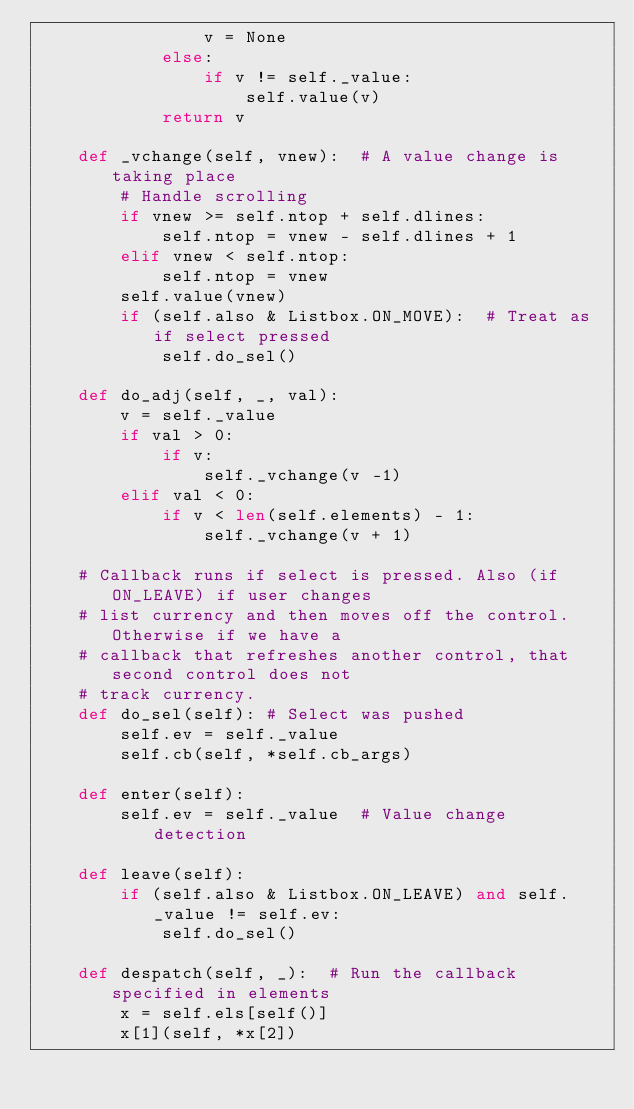Convert code to text. <code><loc_0><loc_0><loc_500><loc_500><_Python_>                v = None
            else:
                if v != self._value:
                    self.value(v)
            return v

    def _vchange(self, vnew):  # A value change is taking place
        # Handle scrolling
        if vnew >= self.ntop + self.dlines:
            self.ntop = vnew - self.dlines + 1
        elif vnew < self.ntop:
            self.ntop = vnew
        self.value(vnew)
        if (self.also & Listbox.ON_MOVE):  # Treat as if select pressed
            self.do_sel()

    def do_adj(self, _, val):
        v = self._value
        if val > 0:
            if v:
                self._vchange(v -1)
        elif val < 0:
            if v < len(self.elements) - 1:
                self._vchange(v + 1)

    # Callback runs if select is pressed. Also (if ON_LEAVE) if user changes
    # list currency and then moves off the control. Otherwise if we have a
    # callback that refreshes another control, that second control does not
    # track currency.
    def do_sel(self): # Select was pushed
        self.ev = self._value
        self.cb(self, *self.cb_args)

    def enter(self):
        self.ev = self._value  # Value change detection

    def leave(self):
        if (self.also & Listbox.ON_LEAVE) and self._value != self.ev:
            self.do_sel()

    def despatch(self, _):  # Run the callback specified in elements
        x = self.els[self()]
        x[1](self, *x[2])
</code> 